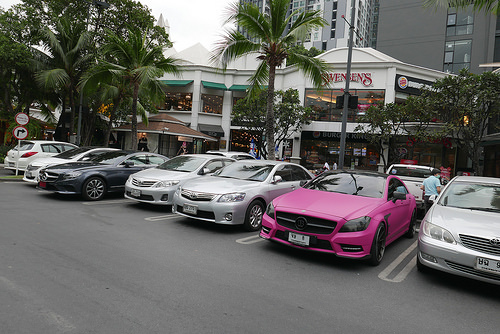<image>
Can you confirm if the car is behind the man? Yes. From this viewpoint, the car is positioned behind the man, with the man partially or fully occluding the car. 